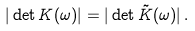<formula> <loc_0><loc_0><loc_500><loc_500>| \det K ( \omega ) | = | \det \tilde { K } ( \omega ) | \, .</formula> 